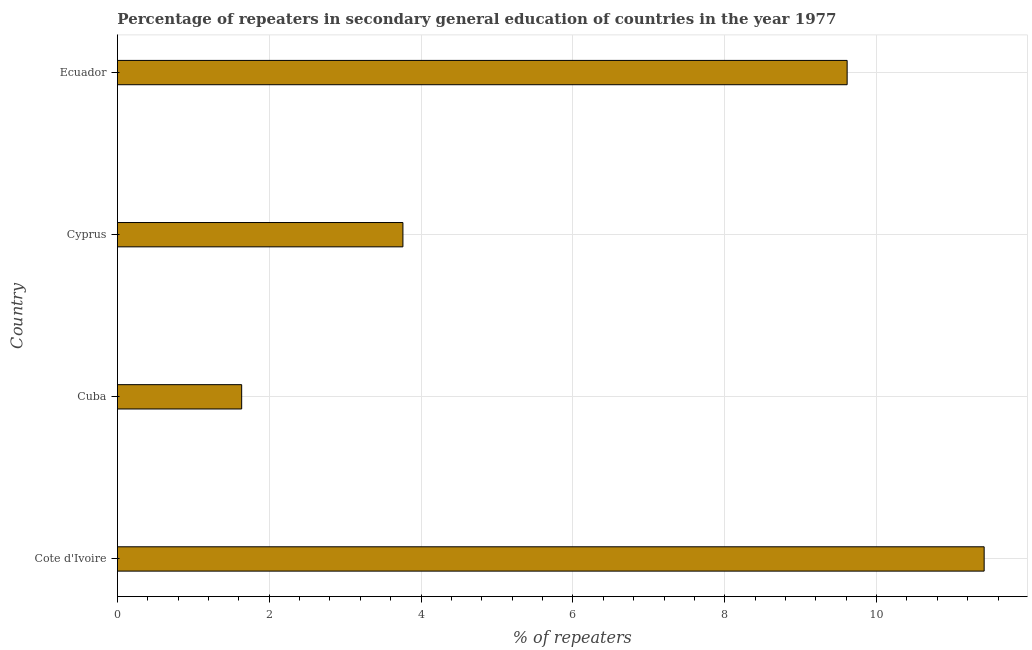Does the graph contain any zero values?
Provide a short and direct response. No. Does the graph contain grids?
Your response must be concise. Yes. What is the title of the graph?
Keep it short and to the point. Percentage of repeaters in secondary general education of countries in the year 1977. What is the label or title of the X-axis?
Your response must be concise. % of repeaters. What is the percentage of repeaters in Cyprus?
Your response must be concise. 3.76. Across all countries, what is the maximum percentage of repeaters?
Ensure brevity in your answer.  11.42. Across all countries, what is the minimum percentage of repeaters?
Your response must be concise. 1.64. In which country was the percentage of repeaters maximum?
Your answer should be compact. Cote d'Ivoire. In which country was the percentage of repeaters minimum?
Your answer should be compact. Cuba. What is the sum of the percentage of repeaters?
Make the answer very short. 26.43. What is the difference between the percentage of repeaters in Cote d'Ivoire and Cyprus?
Provide a succinct answer. 7.66. What is the average percentage of repeaters per country?
Offer a very short reply. 6.61. What is the median percentage of repeaters?
Make the answer very short. 6.69. In how many countries, is the percentage of repeaters greater than 0.8 %?
Make the answer very short. 4. What is the ratio of the percentage of repeaters in Cote d'Ivoire to that in Cyprus?
Ensure brevity in your answer.  3.04. Is the percentage of repeaters in Cyprus less than that in Ecuador?
Your answer should be very brief. Yes. Is the difference between the percentage of repeaters in Cuba and Cyprus greater than the difference between any two countries?
Ensure brevity in your answer.  No. What is the difference between the highest and the second highest percentage of repeaters?
Offer a very short reply. 1.8. What is the difference between the highest and the lowest percentage of repeaters?
Make the answer very short. 9.78. How many bars are there?
Provide a short and direct response. 4. Are all the bars in the graph horizontal?
Provide a short and direct response. Yes. What is the difference between two consecutive major ticks on the X-axis?
Offer a terse response. 2. Are the values on the major ticks of X-axis written in scientific E-notation?
Offer a very short reply. No. What is the % of repeaters in Cote d'Ivoire?
Make the answer very short. 11.42. What is the % of repeaters of Cuba?
Provide a short and direct response. 1.64. What is the % of repeaters of Cyprus?
Keep it short and to the point. 3.76. What is the % of repeaters of Ecuador?
Ensure brevity in your answer.  9.61. What is the difference between the % of repeaters in Cote d'Ivoire and Cuba?
Ensure brevity in your answer.  9.78. What is the difference between the % of repeaters in Cote d'Ivoire and Cyprus?
Your response must be concise. 7.66. What is the difference between the % of repeaters in Cote d'Ivoire and Ecuador?
Provide a short and direct response. 1.8. What is the difference between the % of repeaters in Cuba and Cyprus?
Make the answer very short. -2.12. What is the difference between the % of repeaters in Cuba and Ecuador?
Provide a short and direct response. -7.98. What is the difference between the % of repeaters in Cyprus and Ecuador?
Ensure brevity in your answer.  -5.85. What is the ratio of the % of repeaters in Cote d'Ivoire to that in Cuba?
Give a very brief answer. 6.97. What is the ratio of the % of repeaters in Cote d'Ivoire to that in Cyprus?
Ensure brevity in your answer.  3.04. What is the ratio of the % of repeaters in Cote d'Ivoire to that in Ecuador?
Provide a succinct answer. 1.19. What is the ratio of the % of repeaters in Cuba to that in Cyprus?
Offer a very short reply. 0.43. What is the ratio of the % of repeaters in Cuba to that in Ecuador?
Your answer should be very brief. 0.17. What is the ratio of the % of repeaters in Cyprus to that in Ecuador?
Give a very brief answer. 0.39. 